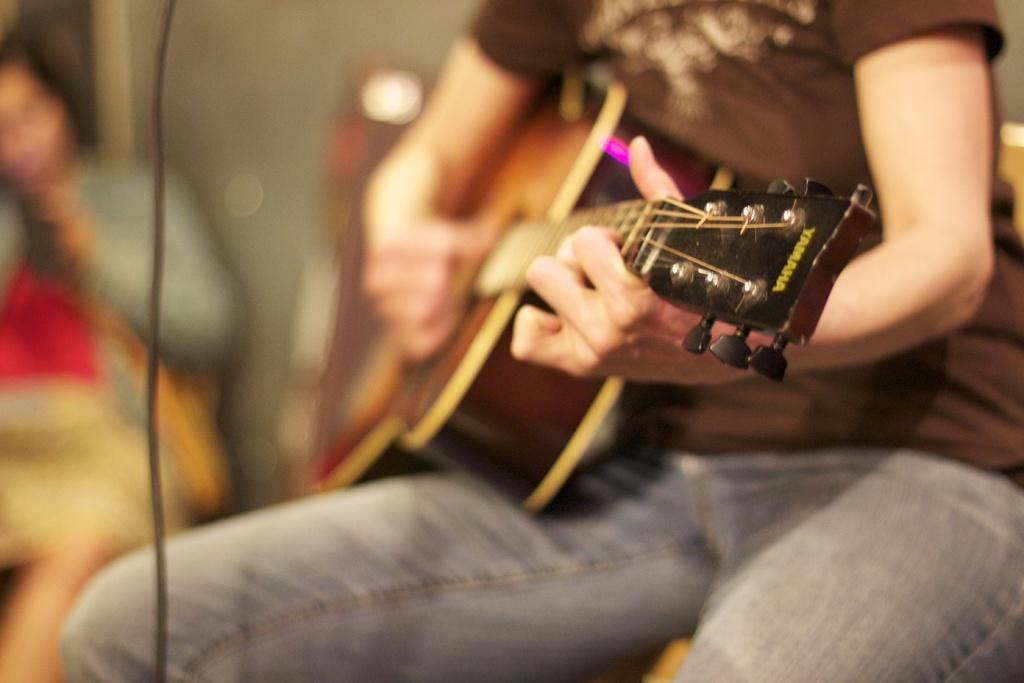What is the main activity being performed by the person in the image? There is a person playing a guitar in the image. Can you describe the position or posture of the other person in the image? There is another person sitting in a chair in the image. How many plates are visible on the floor in the image? There are no plates visible in the image. Are there any spiders crawling on the guitar in the image? There are no spiders present in the image. 